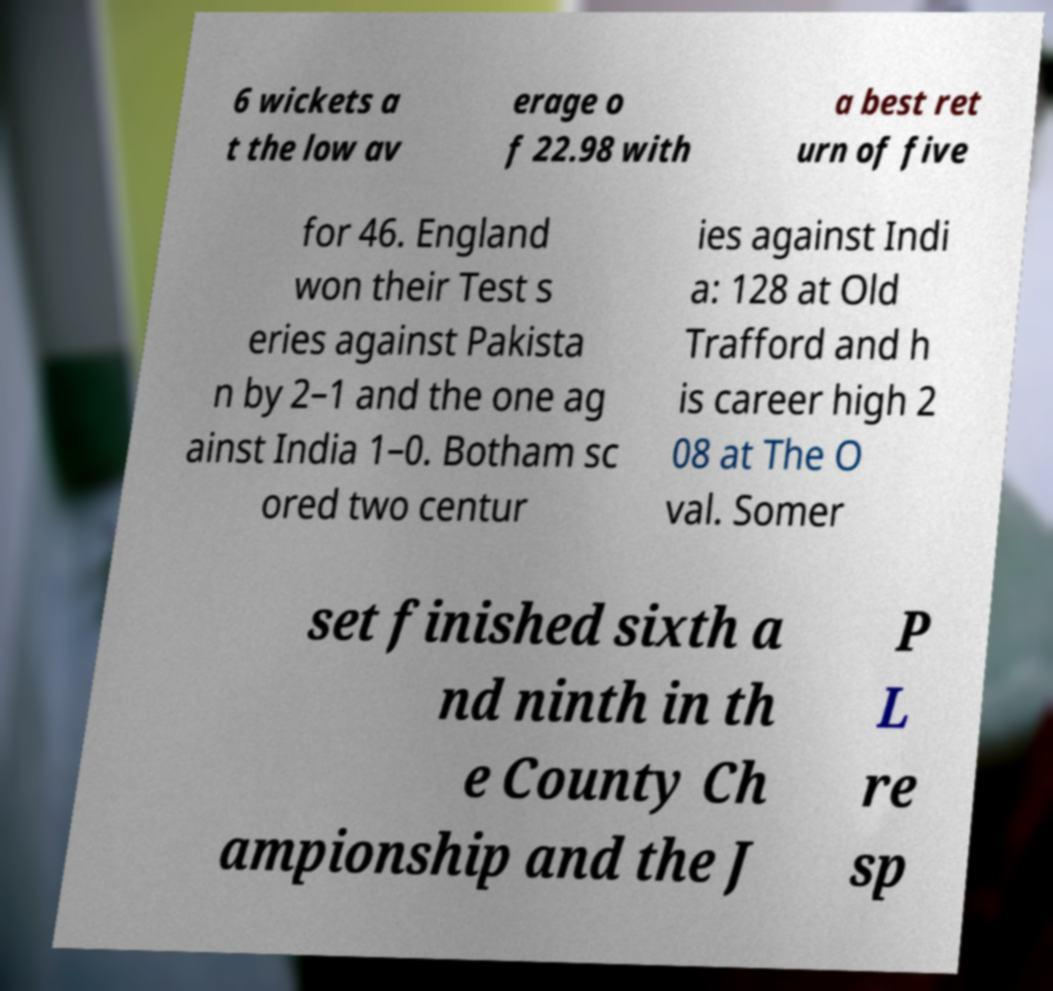Could you assist in decoding the text presented in this image and type it out clearly? 6 wickets a t the low av erage o f 22.98 with a best ret urn of five for 46. England won their Test s eries against Pakista n by 2–1 and the one ag ainst India 1–0. Botham sc ored two centur ies against Indi a: 128 at Old Trafford and h is career high 2 08 at The O val. Somer set finished sixth a nd ninth in th e County Ch ampionship and the J P L re sp 